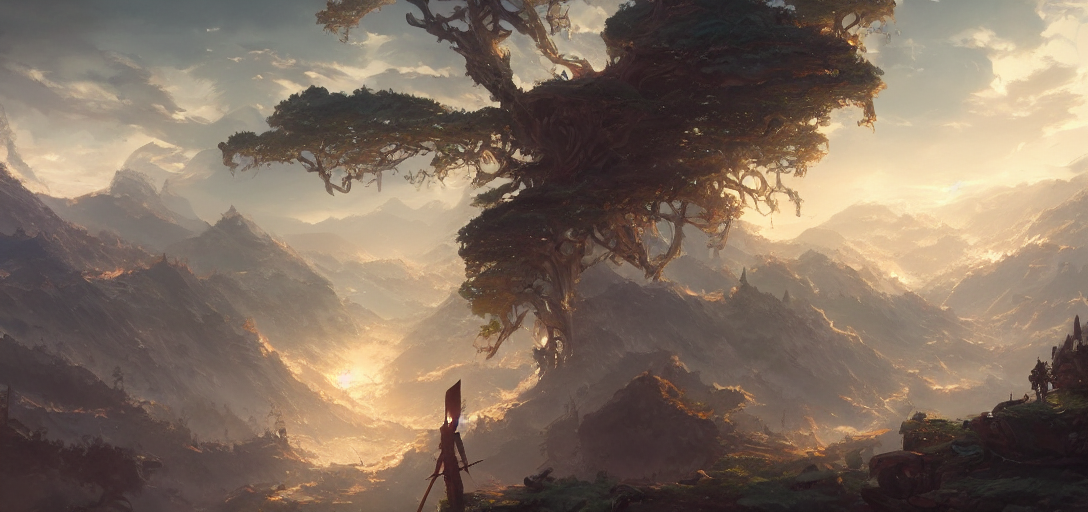Can you describe the atmosphere or mood of this setting? The image creates an atmosphere of tranquility and grandeur. The gentle light filtering through the clouds and the vastness of the landscape contribute to a sense of peace and awe. 